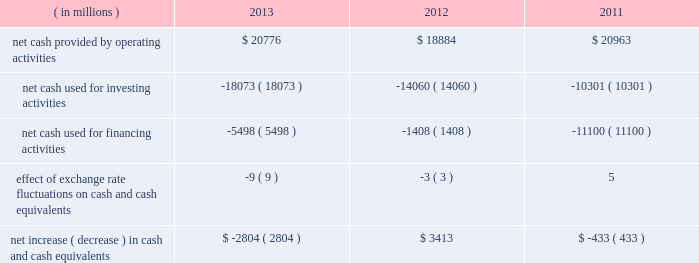In summary , our cash flows for each period were as follows: .
Operating activities cash provided by operating activities is net income adjusted for certain non-cash items and changes in certain assets and liabilities .
For 2013 compared to 2012 , the $ 1.9 billion increase in cash provided by operating activities was due to changes in working capital , partially offset by lower net income in 2013 .
Income taxes paid , net of refunds , in 2013 compared to 2012 were $ 1.1 billion lower due to lower income before taxes in 2013 and 2012 income tax overpayments .
Changes in assets and liabilities as of december 28 , 2013 , compared to december 29 , 2012 , included lower income taxes payable and receivable resulting from a reduction in taxes due in 2013 , and lower inventories due to the sell-through of older-generation products , partially offset by the ramp of 4th generation intel core processor family products .
For 2013 , our three largest customers accounted for 44% ( 44 % ) of our net revenue ( 43% ( 43 % ) in 2012 and 2011 ) , with hewlett- packard company accounting for 17% ( 17 % ) of our net revenue ( 18% ( 18 % ) in 2012 and 19% ( 19 % ) in 2011 ) , dell accounting for 15% ( 15 % ) of our net revenue ( 14% ( 14 % ) in 2012 and 15% ( 15 % ) in 2011 ) , and lenovo accounting for 12% ( 12 % ) of our net revenue ( 11% ( 11 % ) in 2012 and 9% ( 9 % ) in 2011 ) .
These three customers accounted for 34% ( 34 % ) of our accounts receivable as of december 28 , 2013 ( 33% ( 33 % ) as of december 29 , 2012 ) .
For 2012 compared to 2011 , the $ 2.1 billion decrease in cash provided by operating activities was due to lower net income and changes in our working capital , partially offset by adjustments for non-cash items .
The adjustments for noncash items were higher due primarily to higher depreciation in 2012 compared to 2011 , partially offset by increases in non-acquisition-related deferred tax liabilities as of december 31 , 2011 .
Investing activities investing cash flows consist primarily of capital expenditures ; investment purchases , sales , maturities , and disposals ; as well as cash used for acquisitions .
The increase in cash used for investing activities in 2013 compared to 2012 was primarily due to an increase in purchases of available-for-sale investments and a decrease in maturities and sales of trading assets , partially offset by an increase in maturities and sales of available-for-sale investments and a decrease in purchases of licensed technology and patents .
Our capital expenditures were $ 10.7 billion in 2013 ( $ 11.0 billion in 2012 and $ 10.8 billion in 2011 ) .
Cash used for investing activities increased in 2012 compared to 2011 primarily due to net purchases of available- for-sale investments and trading assets in 2012 , as compared to net maturities and sales of available-for-sale investments and trading assets in 2011 , partially offset by a decrease in cash paid for acquisitions .
Net purchases of available-for-sale investments in 2012 included our purchase of $ 3.2 billion of equity securities in asml in q3 2012 .
Financing activities financing cash flows consist primarily of repurchases of common stock , payment of dividends to stockholders , issuance and repayment of long-term debt , and proceeds from the sale of shares through employee equity incentive plans .
Table of contents management 2019s discussion and analysis of financial condition and results of operations ( continued ) .
What was the percentage change in net cash provided by operating activities between 2012 and 2013? 
Computations: ((20776 - 18884) / 18884)
Answer: 0.10019. 